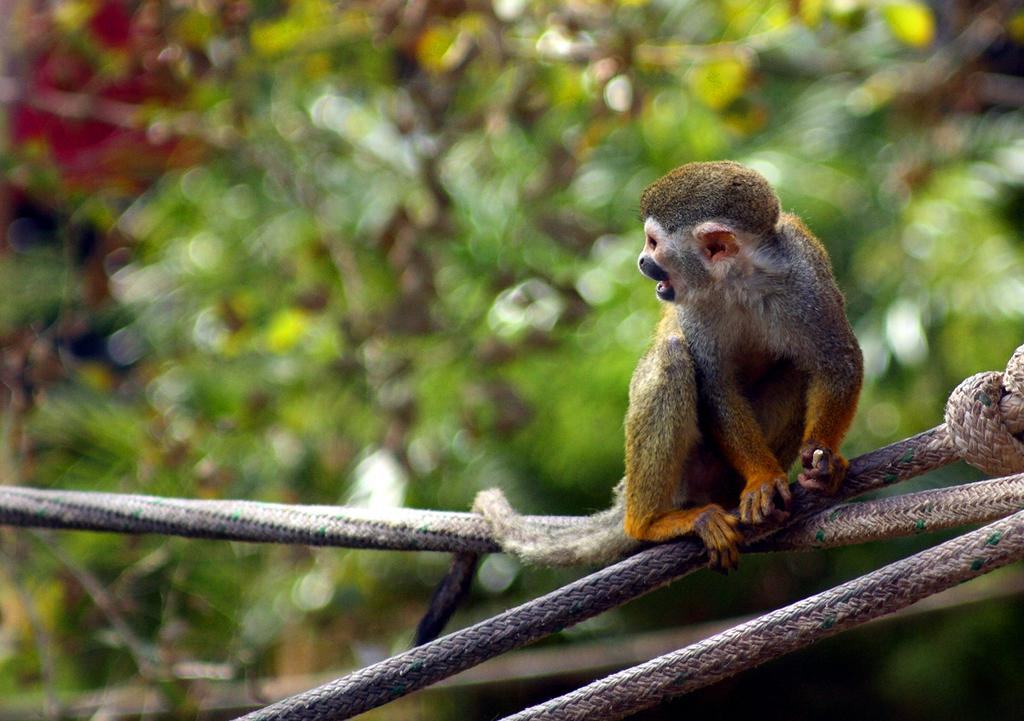What type of animal can be seen in the image? There is an animal in the image that resembles a monkey. What is the animal doing in the image? The animal is sitting on ropes. What can be seen in the background of the image? There are trees visible in the background of the image. How would you describe the background of the image? The background is blurred. What color is the sweater the animal is wearing in the image? There is no sweater present in the image, as the animal is not wearing any clothing. 